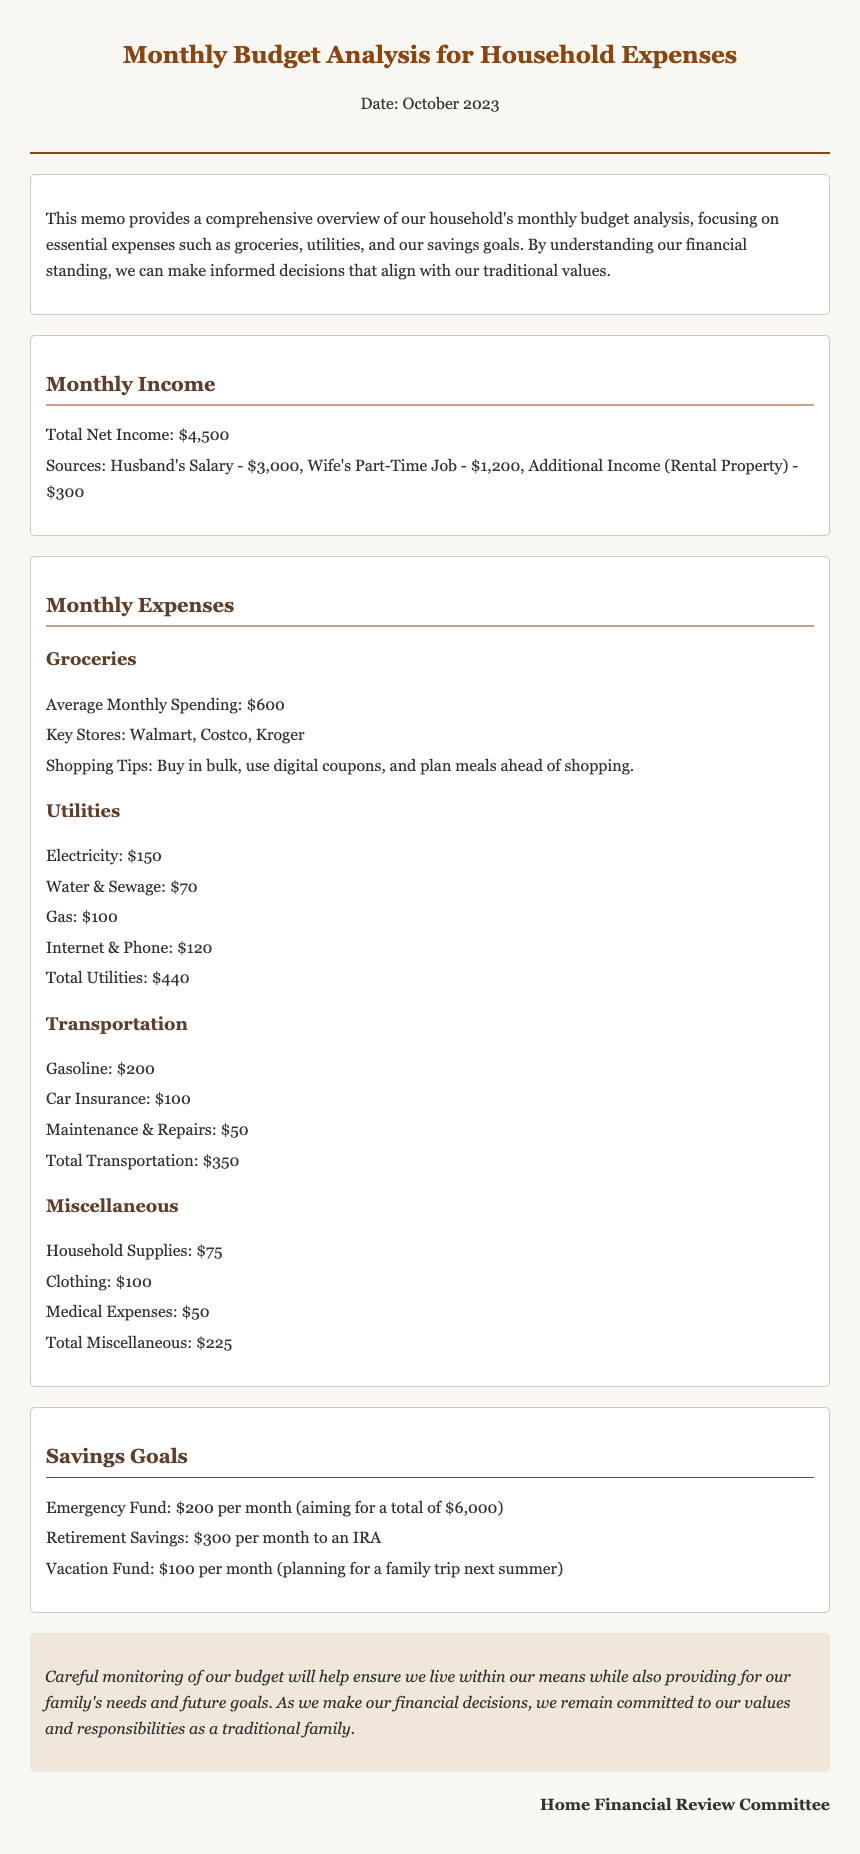What is the total net income? The total net income is specified in the document as the sum of various sources, which is $3,000 + $1,200 + $300 = $4,500.
Answer: $4,500 What is the average monthly spending on groceries? The document states that the average monthly spending on groceries is clearly mentioned under the groceries section.
Answer: $600 What are the key stores for grocery shopping? Key stores for grocery shopping are listed in the groceries section of the memo.
Answer: Walmart, Costco, Kroger How much is allocated for the emergency fund per month? The monthly allocation for the emergency fund is stated in the savings goals section.
Answer: $200 What is the total monthly spending on utilities? The total spending on utilities is calculated from the listed utility expenses in the memo.
Answer: $440 What is the amount set aside for retirement savings? The document specifies the amount that is set aside for retirement savings under the savings goals section.
Answer: $300 What is the total spending for miscellaneous expenses? The total spending for miscellaneous expenses can be calculated from the listed items in that section.
Answer: $225 What is the goal for the vacation fund each month? The monthly goal for the vacation fund is indicated in the savings goals section of the document.
Answer: $100 What is the purpose of this memo? The purpose of the memo is outlined in the introductory paragraph, focusing on analyzing household expenses.
Answer: Monthly budget analysis 